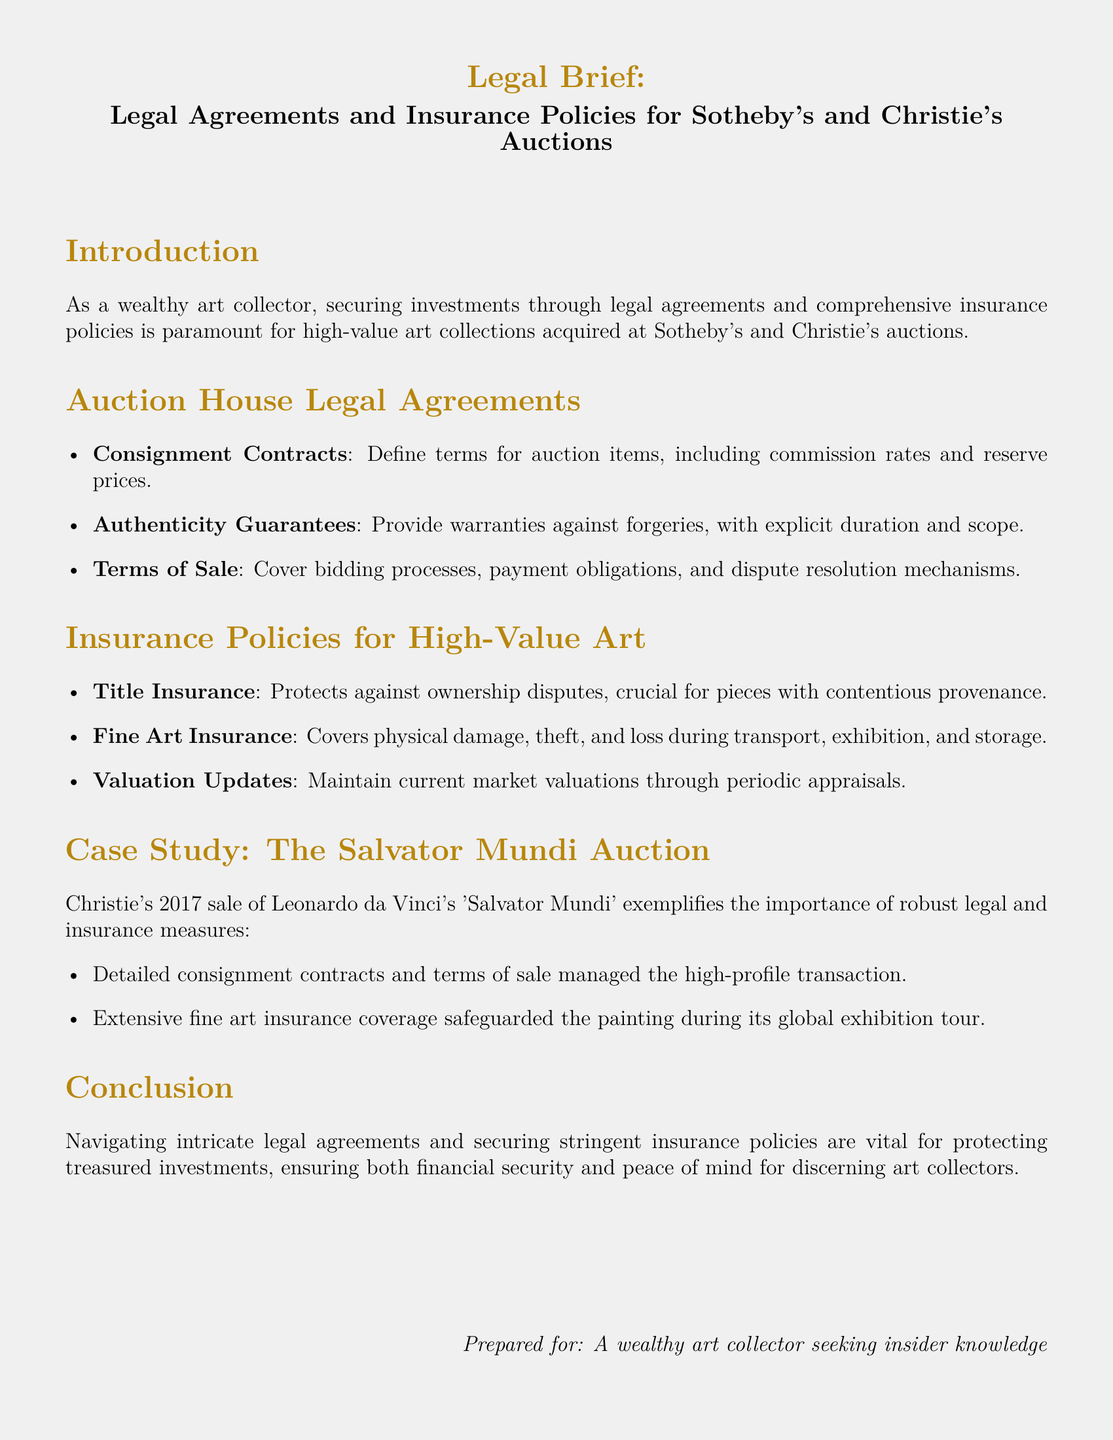What are consignment contracts? Consignment contracts are legal agreements that define terms for auction items, including commission rates and reserve prices.
Answer: Legal agreements What type of insurance protects against ownership disputes? Title insurance is specifically designed to protect against ownership disputes.
Answer: Title insurance What is covered by fine art insurance? Fine art insurance covers physical damage, theft, and loss during transport, exhibition, and storage.
Answer: Physical damage, theft, and loss What major auction involved the Salvator Mundi? The major auction involved the Salvator Mundi was Christie's 2017 sale.
Answer: Christie's 2017 sale What is the benefit of periodic appraisals? Periodic appraisals maintain current market valuations for high-value art.
Answer: Current market valuations What critical aspect does the case study illustrate? The case study illustrates the importance of robust legal and insurance measures.
Answer: Robust legal and insurance measures What does the introduction emphasize for art collectors? The introduction emphasizes securing investments through legal agreements and comprehensive insurance policies.
Answer: Securing investments What auction house is known for authenticity guarantees? Sotheby's is known for authenticity guarantees.
Answer: Sotheby's 